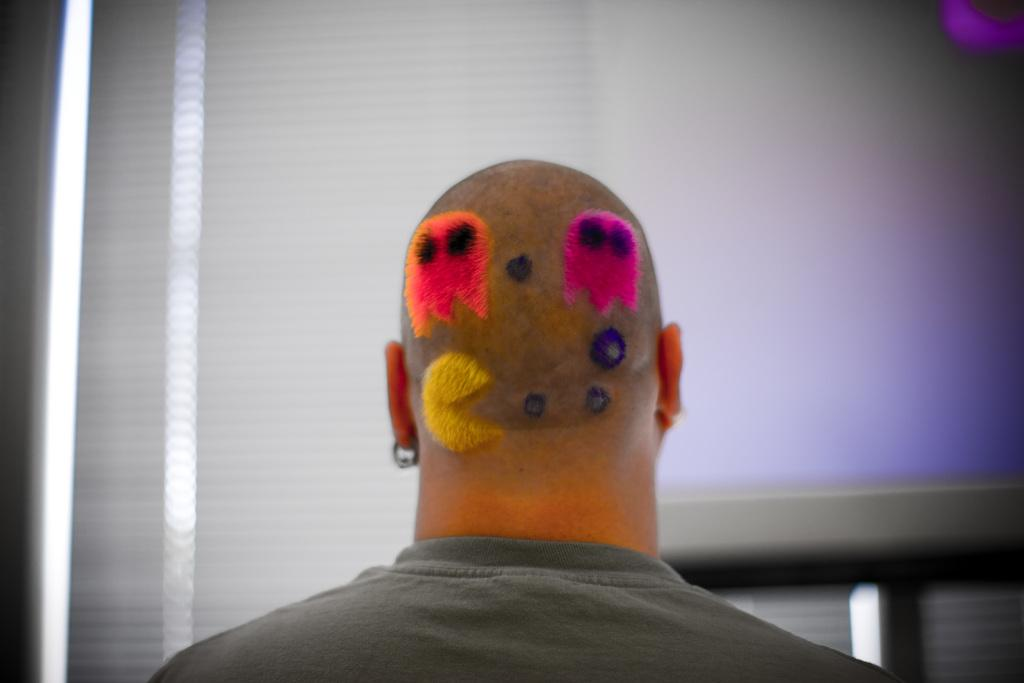What is the main subject of the image? The main subject of the image is a man. Can you describe a unique feature of the man in the image? The man has a PAC-MAN hair style on his back. How much salt is present in the image? There is no salt present in the image. Can you describe the pickle's shape in the image? There is no pickle present in the image. 